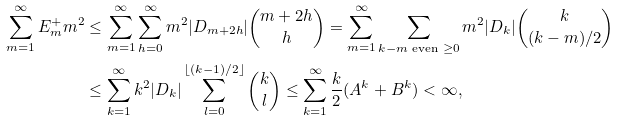Convert formula to latex. <formula><loc_0><loc_0><loc_500><loc_500>\sum _ { m = 1 } ^ { \infty } E _ { m } ^ { + } m ^ { 2 } & \leq \sum _ { m = 1 } ^ { \infty } \sum _ { h = 0 } ^ { \infty } m ^ { 2 } | D _ { m + 2 h } | \binom { m + 2 h } { h } = \sum _ { m = 1 } ^ { \infty } \sum _ { k - m \text { even } \geq 0 } m ^ { 2 } | D _ { k } | \binom { k } { ( k - m ) / 2 } \\ & \leq \sum _ { k = 1 } ^ { \infty } k ^ { 2 } | D _ { k } | \sum _ { l = 0 } ^ { \lfloor ( k - 1 ) / 2 \rfloor } \binom { k } { l } \leq \sum _ { k = 1 } ^ { \infty } \frac { k } { 2 } ( A ^ { k } + B ^ { k } ) < \infty ,</formula> 